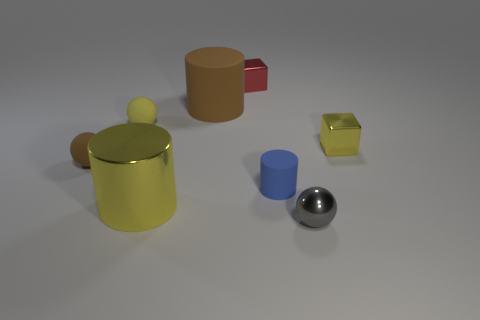Add 1 yellow shiny cylinders. How many objects exist? 9 Subtract all cylinders. How many objects are left? 5 Add 3 big yellow metallic things. How many big yellow metallic things are left? 4 Add 2 large cyan rubber balls. How many large cyan rubber balls exist? 2 Subtract 0 brown cubes. How many objects are left? 8 Subtract all tiny brown spheres. Subtract all brown balls. How many objects are left? 6 